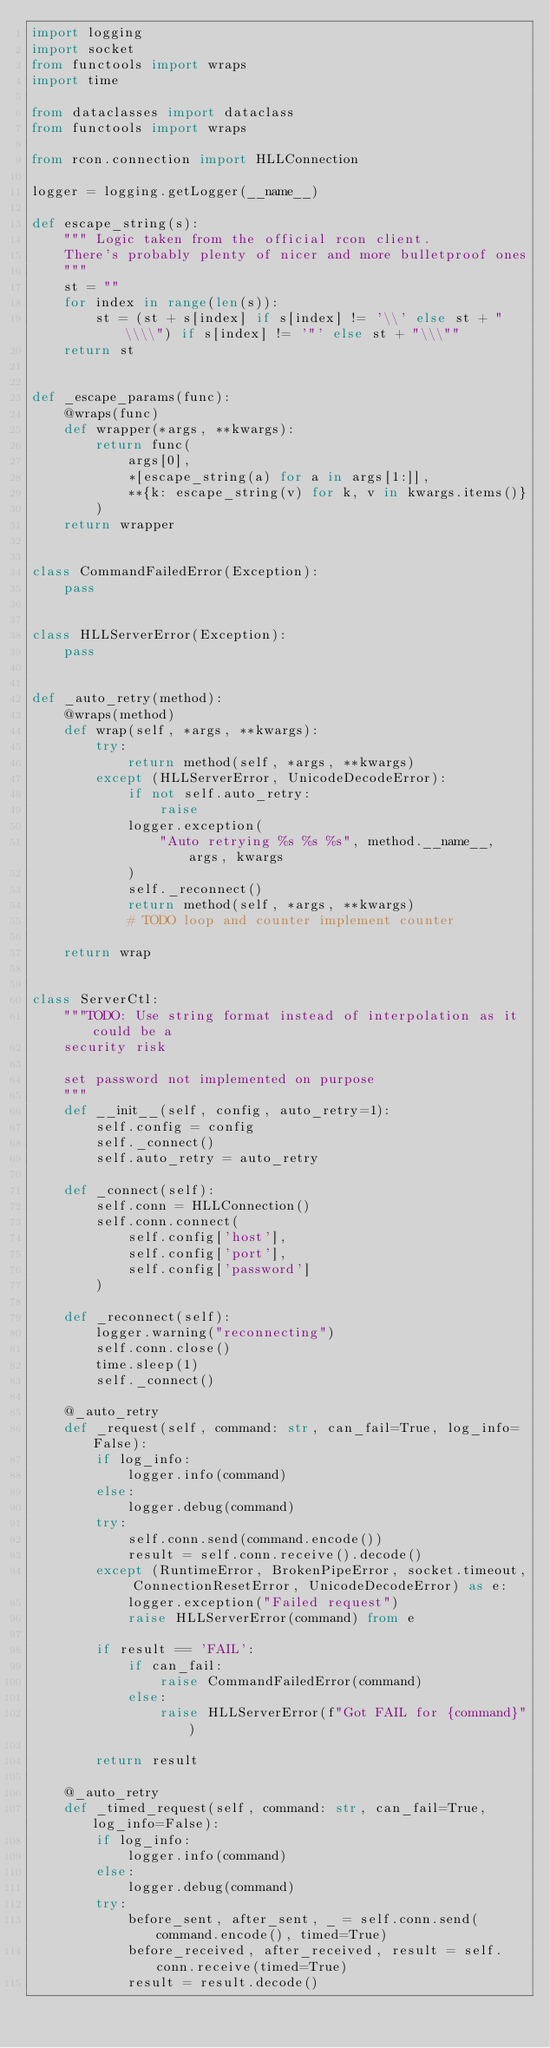Convert code to text. <code><loc_0><loc_0><loc_500><loc_500><_Python_>import logging
import socket
from functools import wraps
import time

from dataclasses import dataclass
from functools import wraps

from rcon.connection import HLLConnection

logger = logging.getLogger(__name__)

def escape_string(s):
    """ Logic taken from the official rcon client.
    There's probably plenty of nicer and more bulletproof ones
    """
    st = ""
    for index in range(len(s)):
        st = (st + s[index] if s[index] != '\\' else st + "\\\\") if s[index] != '"' else st + "\\\""
    return st


def _escape_params(func):
    @wraps(func)
    def wrapper(*args, **kwargs):
        return func(
            args[0],
            *[escape_string(a) for a in args[1:]],
            **{k: escape_string(v) for k, v in kwargs.items()}
        )
    return wrapper


class CommandFailedError(Exception):
    pass


class HLLServerError(Exception):
    pass


def _auto_retry(method):
    @wraps(method)
    def wrap(self, *args, **kwargs):
        try:
            return method(self, *args, **kwargs)
        except (HLLServerError, UnicodeDecodeError):
            if not self.auto_retry:
                raise
            logger.exception(
                "Auto retrying %s %s %s", method.__name__, args, kwargs
            )
            self._reconnect()
            return method(self, *args, **kwargs)
            # TODO loop and counter implement counter

    return wrap


class ServerCtl:
    """TODO: Use string format instead of interpolation as it could be a
    security risk

    set password not implemented on purpose
    """
    def __init__(self, config, auto_retry=1):
        self.config = config
        self._connect()
        self.auto_retry = auto_retry

    def _connect(self):
        self.conn = HLLConnection()
        self.conn.connect(
            self.config['host'],
            self.config['port'],
            self.config['password']
        )

    def _reconnect(self):
        logger.warning("reconnecting")
        self.conn.close()
        time.sleep(1)
        self._connect()

    @_auto_retry
    def _request(self, command: str, can_fail=True, log_info=False):
        if log_info:
            logger.info(command)
        else:
            logger.debug(command)
        try:
            self.conn.send(command.encode())
            result = self.conn.receive().decode()
        except (RuntimeError, BrokenPipeError, socket.timeout, ConnectionResetError, UnicodeDecodeError) as e:
            logger.exception("Failed request")
            raise HLLServerError(command) from e

        if result == 'FAIL':
            if can_fail:
                raise CommandFailedError(command)
            else:
                raise HLLServerError(f"Got FAIL for {command}")

        return result

    @_auto_retry
    def _timed_request(self, command: str, can_fail=True, log_info=False):
        if log_info:
            logger.info(command)
        else:
            logger.debug(command)
        try:
            before_sent, after_sent, _ = self.conn.send(command.encode(), timed=True)
            before_received, after_received, result = self.conn.receive(timed=True)
            result = result.decode()</code> 